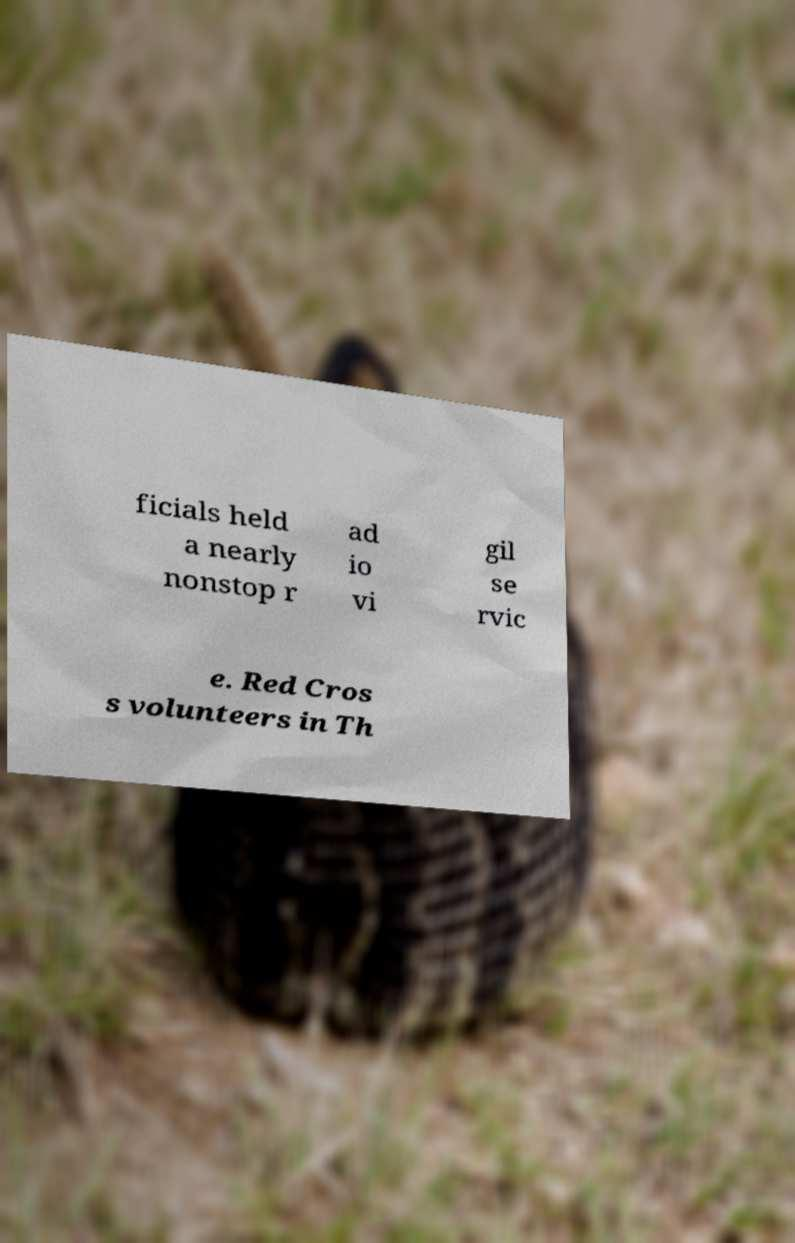Could you assist in decoding the text presented in this image and type it out clearly? ficials held a nearly nonstop r ad io vi gil se rvic e. Red Cros s volunteers in Th 